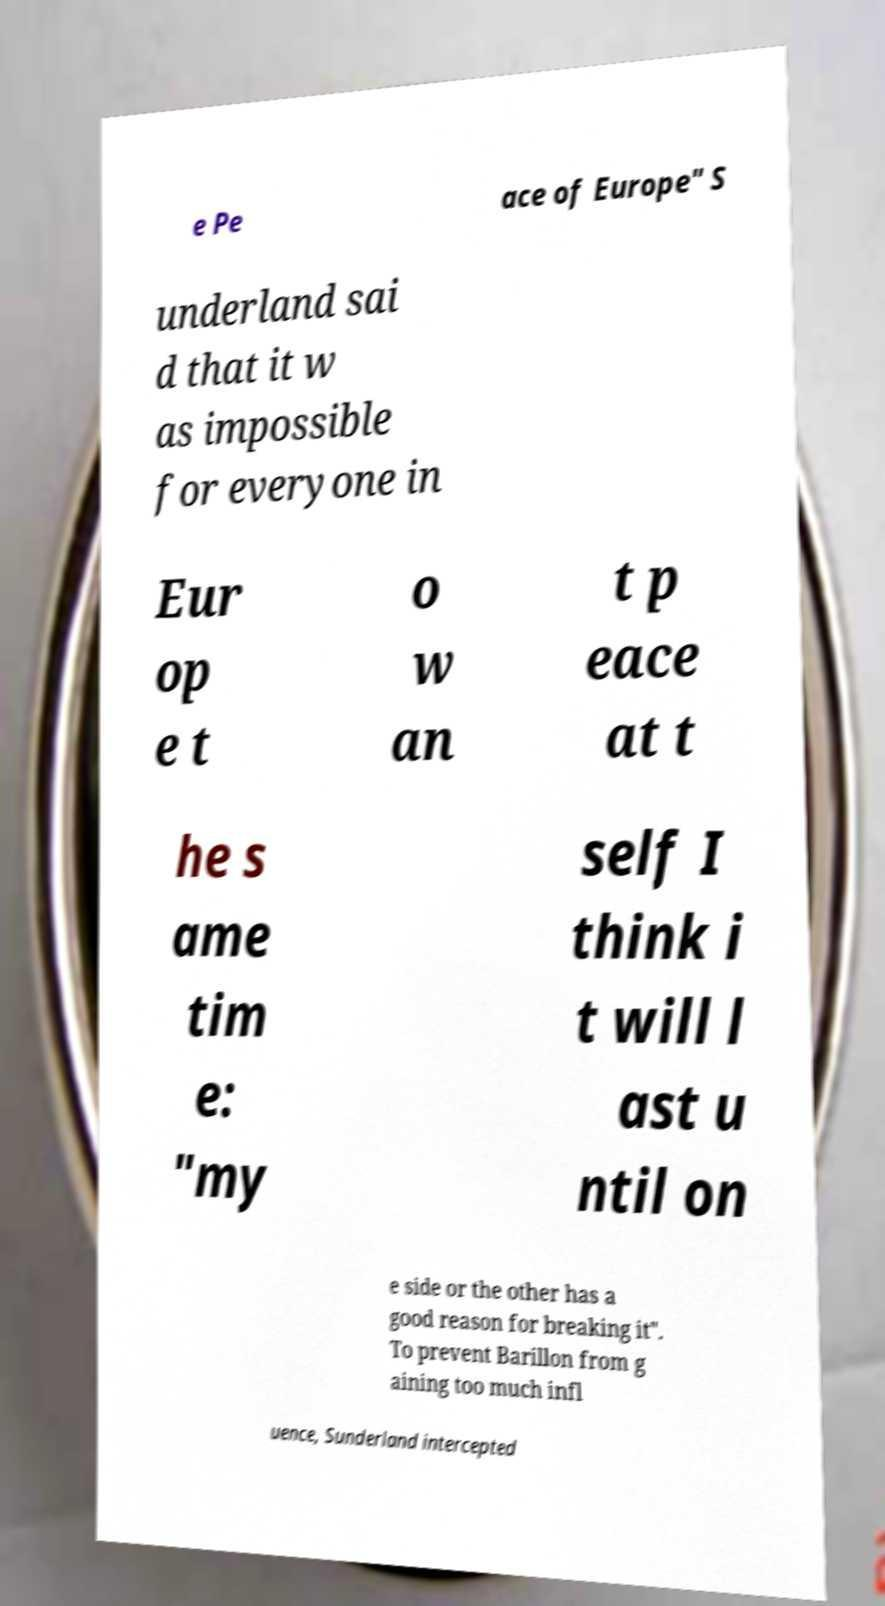There's text embedded in this image that I need extracted. Can you transcribe it verbatim? e Pe ace of Europe" S underland sai d that it w as impossible for everyone in Eur op e t o w an t p eace at t he s ame tim e: "my self I think i t will l ast u ntil on e side or the other has a good reason for breaking it". To prevent Barillon from g aining too much infl uence, Sunderland intercepted 